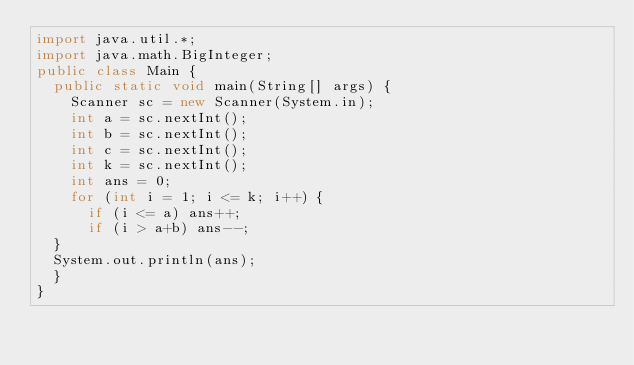<code> <loc_0><loc_0><loc_500><loc_500><_Java_>import java.util.*;
import java.math.BigInteger;
public class Main {
  public static void main(String[] args) {
    Scanner sc = new Scanner(System.in);
    int a = sc.nextInt();
    int b = sc.nextInt();
    int c = sc.nextInt();
    int k = sc.nextInt();
    int ans = 0;
    for (int i = 1; i <= k; i++) {
      if (i <= a) ans++;
      if (i > a+b) ans--;
  }
  System.out.println(ans);
  }
}
</code> 